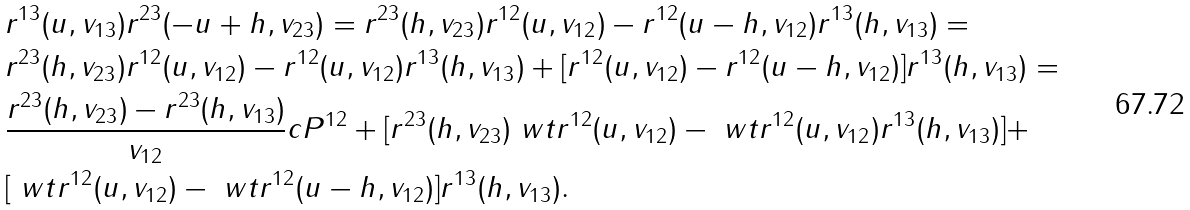<formula> <loc_0><loc_0><loc_500><loc_500>& r ^ { 1 3 } ( u , v _ { 1 3 } ) r ^ { 2 3 } ( - u + h , v _ { 2 3 } ) = r ^ { 2 3 } ( h , v _ { 2 3 } ) r ^ { 1 2 } ( u , v _ { 1 2 } ) - r ^ { 1 2 } ( u - h , v _ { 1 2 } ) r ^ { 1 3 } ( h , v _ { 1 3 } ) = \\ & r ^ { 2 3 } ( h , v _ { 2 3 } ) r ^ { 1 2 } ( u , v _ { 1 2 } ) - r ^ { 1 2 } ( u , v _ { 1 2 } ) r ^ { 1 3 } ( h , v _ { 1 3 } ) + [ r ^ { 1 2 } ( u , v _ { 1 2 } ) - r ^ { 1 2 } ( u - h , v _ { 1 2 } ) ] r ^ { 1 3 } ( h , v _ { 1 3 } ) = \\ & \frac { r ^ { 2 3 } ( h , v _ { 2 3 } ) - r ^ { 2 3 } ( h , v _ { 1 3 } ) } { v _ { 1 2 } } c P ^ { 1 2 } + [ r ^ { 2 3 } ( h , v _ { 2 3 } ) \ w t { r } ^ { 1 2 } ( u , v _ { 1 2 } ) - \ w t { r } ^ { 1 2 } ( u , v _ { 1 2 } ) r ^ { 1 3 } ( h , v _ { 1 3 } ) ] + \\ & [ \ w t { r } ^ { 1 2 } ( u , v _ { 1 2 } ) - \ w t { r } ^ { 1 2 } ( u - h , v _ { 1 2 } ) ] r ^ { 1 3 } ( h , v _ { 1 3 } ) .</formula> 